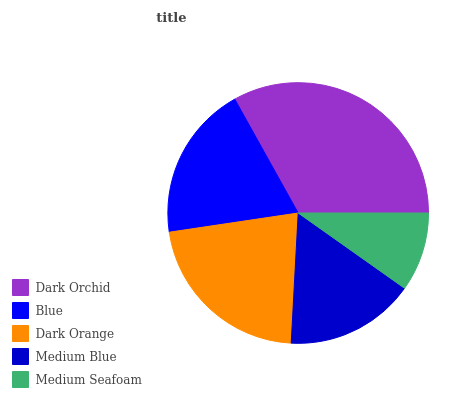Is Medium Seafoam the minimum?
Answer yes or no. Yes. Is Dark Orchid the maximum?
Answer yes or no. Yes. Is Blue the minimum?
Answer yes or no. No. Is Blue the maximum?
Answer yes or no. No. Is Dark Orchid greater than Blue?
Answer yes or no. Yes. Is Blue less than Dark Orchid?
Answer yes or no. Yes. Is Blue greater than Dark Orchid?
Answer yes or no. No. Is Dark Orchid less than Blue?
Answer yes or no. No. Is Blue the high median?
Answer yes or no. Yes. Is Blue the low median?
Answer yes or no. Yes. Is Medium Seafoam the high median?
Answer yes or no. No. Is Medium Seafoam the low median?
Answer yes or no. No. 